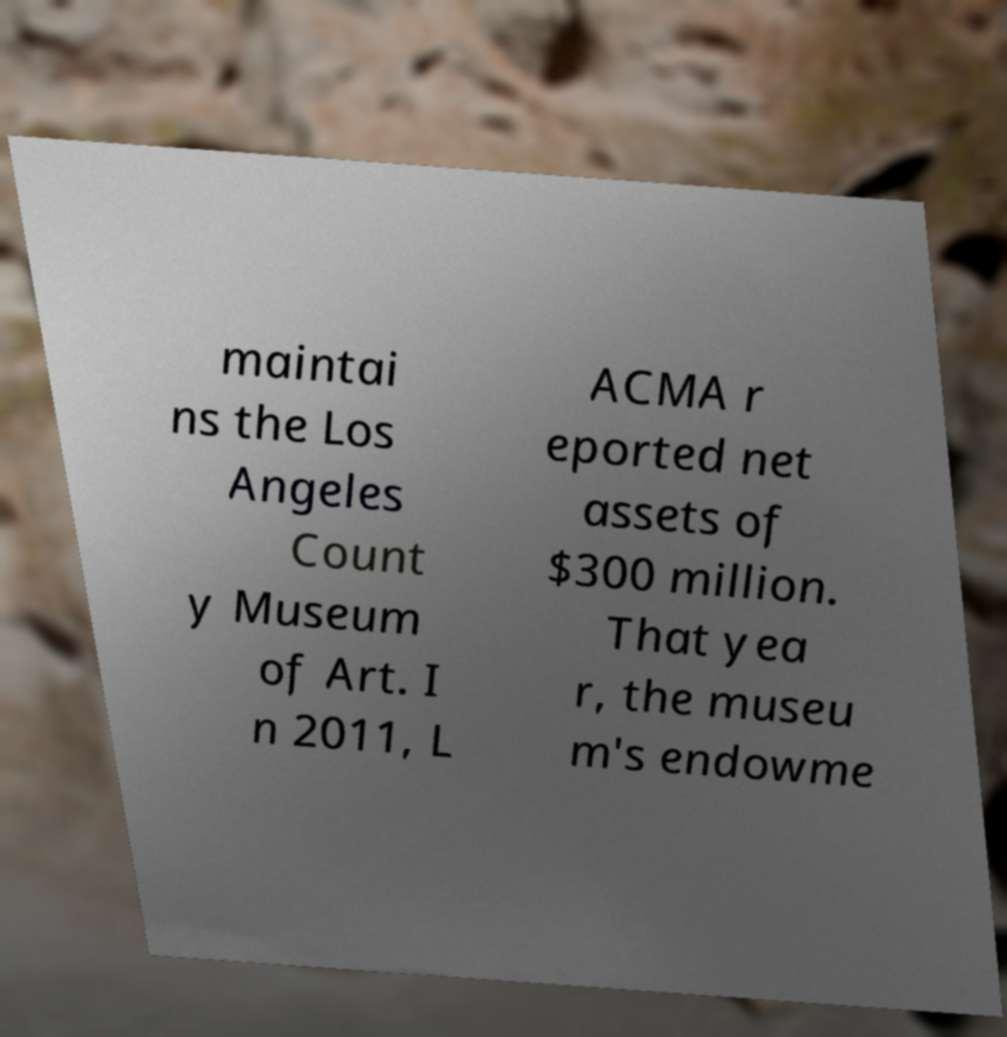Can you read and provide the text displayed in the image?This photo seems to have some interesting text. Can you extract and type it out for me? maintai ns the Los Angeles Count y Museum of Art. I n 2011, L ACMA r eported net assets of $300 million. That yea r, the museu m's endowme 